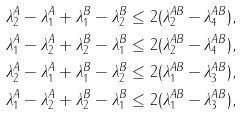<formula> <loc_0><loc_0><loc_500><loc_500>\lambda ^ { A } _ { 2 } - \lambda ^ { A } _ { 1 } + \lambda ^ { B } _ { 1 } - \lambda ^ { B } _ { 2 } & \leq 2 ( \lambda ^ { A B } _ { 2 } - \lambda ^ { A B } _ { 4 } ) , \\ \lambda ^ { A } _ { 1 } - \lambda ^ { A } _ { 2 } + \lambda ^ { B } _ { 2 } - \lambda ^ { B } _ { 1 } & \leq 2 ( \lambda ^ { A B } _ { 2 } - \lambda ^ { A B } _ { 4 } ) , \\ \lambda ^ { A } _ { 2 } - \lambda ^ { A } _ { 1 } + \lambda ^ { B } _ { 1 } - \lambda ^ { B } _ { 2 } & \leq 2 ( \lambda ^ { A B } _ { 1 } - \lambda ^ { A B } _ { 3 } ) , \\ \lambda ^ { A } _ { 1 } - \lambda ^ { A } _ { 2 } + \lambda ^ { B } _ { 2 } - \lambda ^ { B } _ { 1 } & \leq 2 ( \lambda ^ { A B } _ { 1 } - \lambda ^ { A B } _ { 3 } ) ,</formula> 